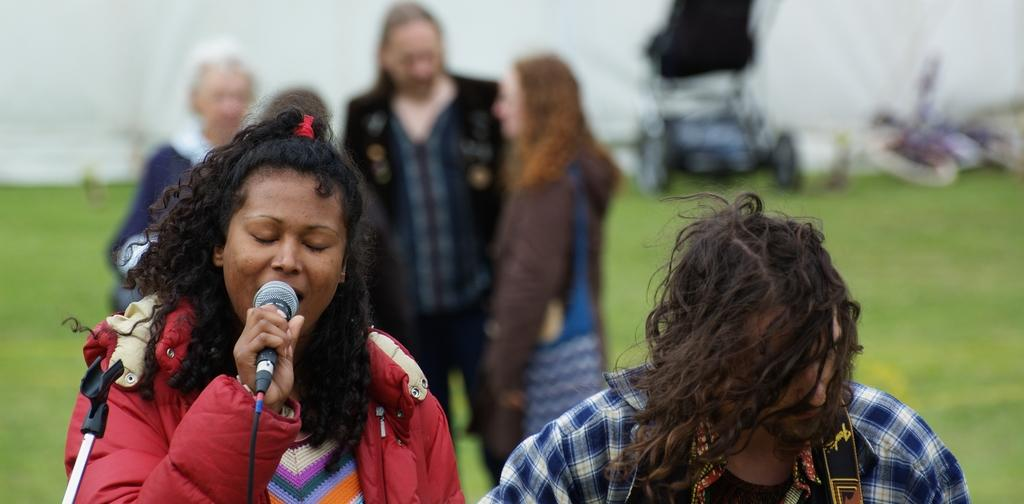How many people are present in the image? There are two people in the image. What is one person doing with their hands? One person is holding a microphone. What object is used to support the microphone in the image? There is a microphone stand in the image. How many people are in the background of the image? There are three people standing in the background. What type of natural environment is visible in the image? There is grass visible in the image. What type of worm can be seen crawling on the microphone stand in the image? There is no worm present in the image; it only features two people, a microphone, and a microphone stand. 